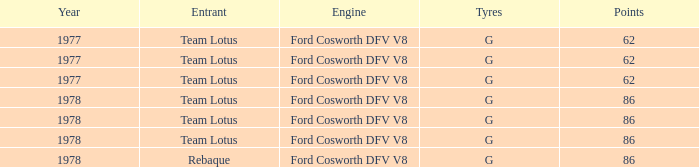Identify the focus that has a year beyond 1977. 86, 86, 86, 86. 